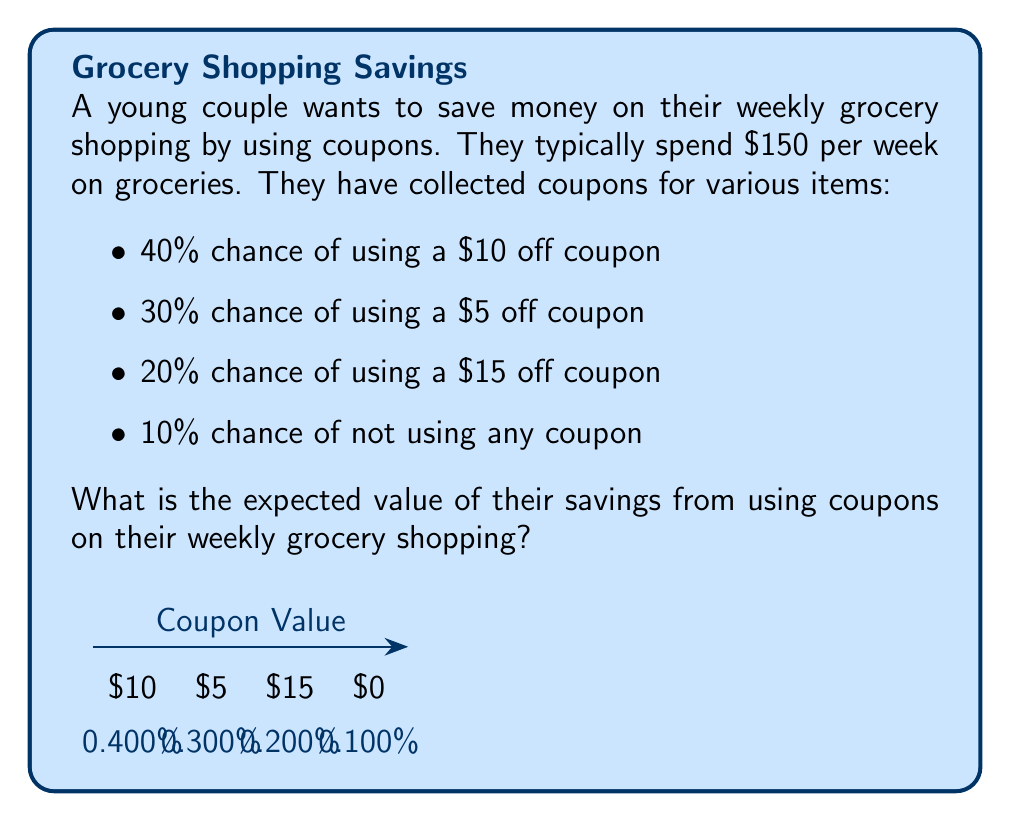Solve this math problem. To solve this problem, we need to calculate the expected value of the savings. The expected value is the sum of each possible outcome multiplied by its probability.

Let's break it down step-by-step:

1) First, let's list out our possible outcomes and their probabilities:
   - $10 off with 40% probability (0.4)
   - $5 off with 30% probability (0.3)
   - $15 off with 20% probability (0.2)
   - $0 off (no coupon) with 10% probability (0.1)

2) Now, let's calculate the expected value using the formula:

   $$ E(X) = \sum_{i=1}^{n} x_i \cdot p(x_i) $$

   Where $x_i$ is the value of each outcome and $p(x_i)$ is its probability.

3) Let's plug in our values:

   $$ E(X) = 10 \cdot 0.4 + 5 \cdot 0.3 + 15 \cdot 0.2 + 0 \cdot 0.1 $$

4) Now, let's calculate each term:
   
   $$ E(X) = 4 + 1.5 + 3 + 0 $$

5) Finally, sum up all terms:

   $$ E(X) = 8.5 $$

Therefore, the expected value of their savings from using coupons on their weekly grocery shopping is $8.50.
Answer: $8.50 